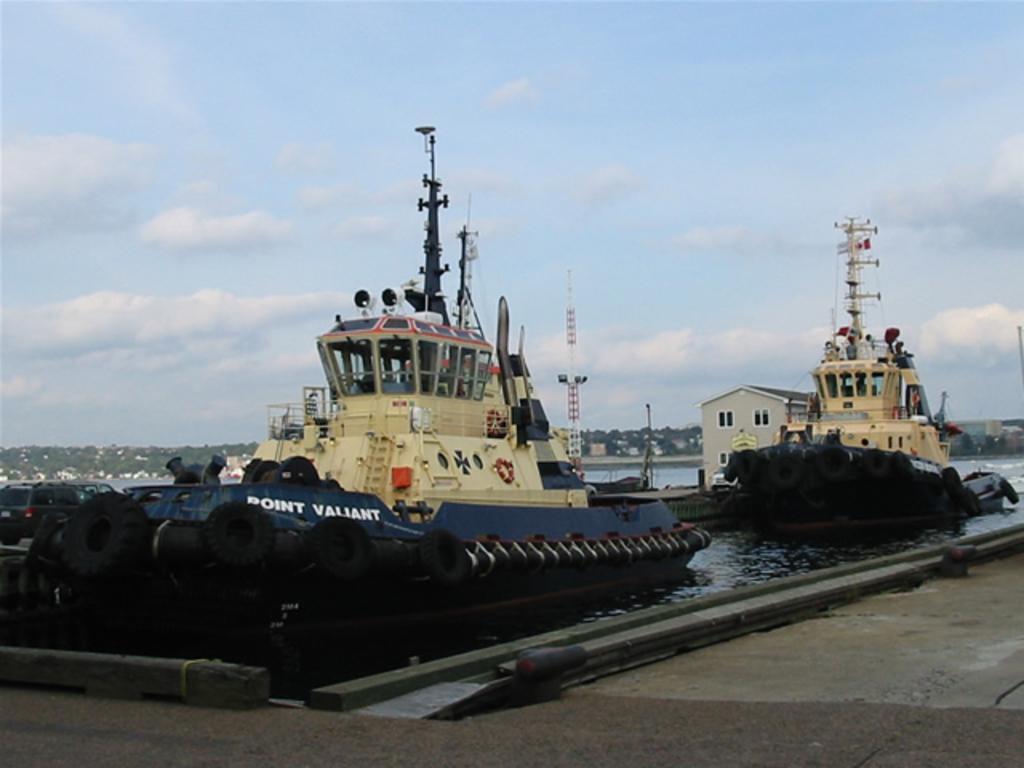Describe this image in one or two sentences. In this picture we can see tyres, swim tubes, tower, poles, house with windows, ships on water, path, trees and some objects and in the background we can see the sky with clouds. 